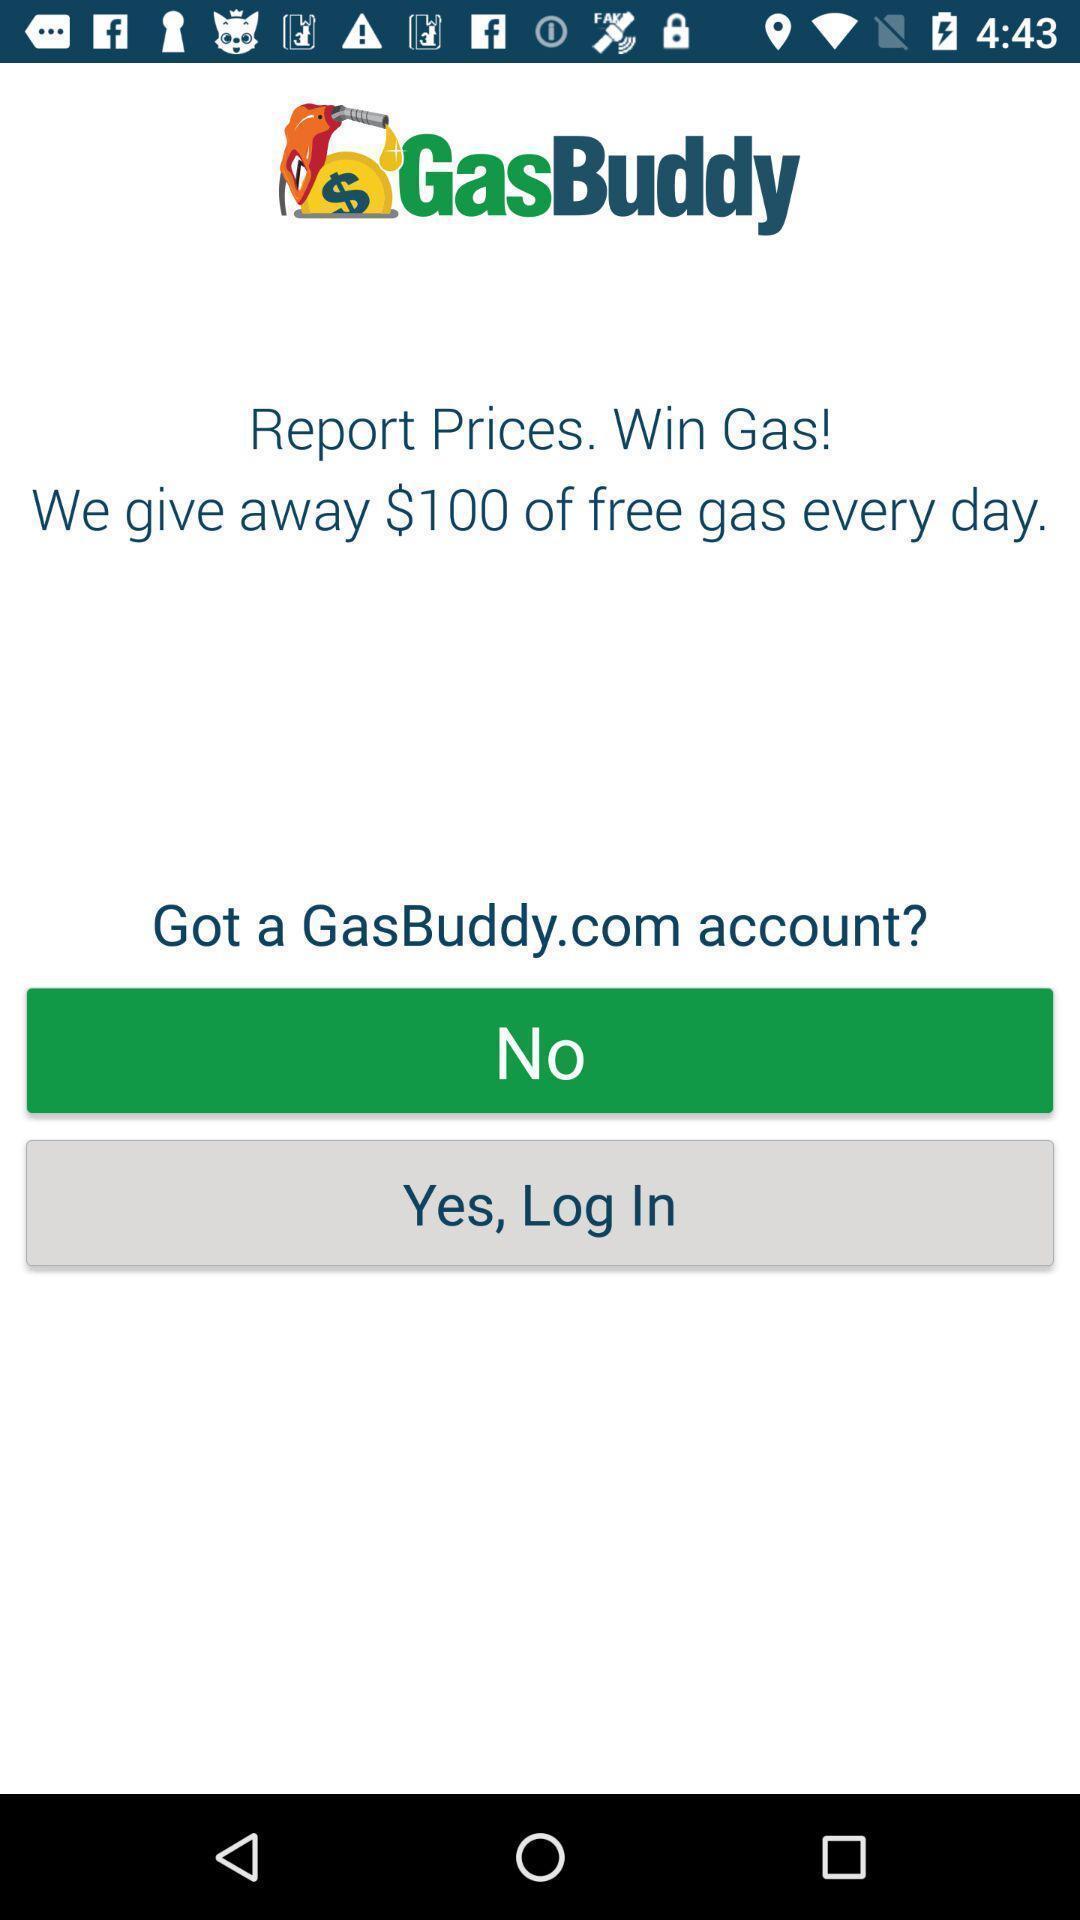Describe the content in this image. Welcome page with login option. 